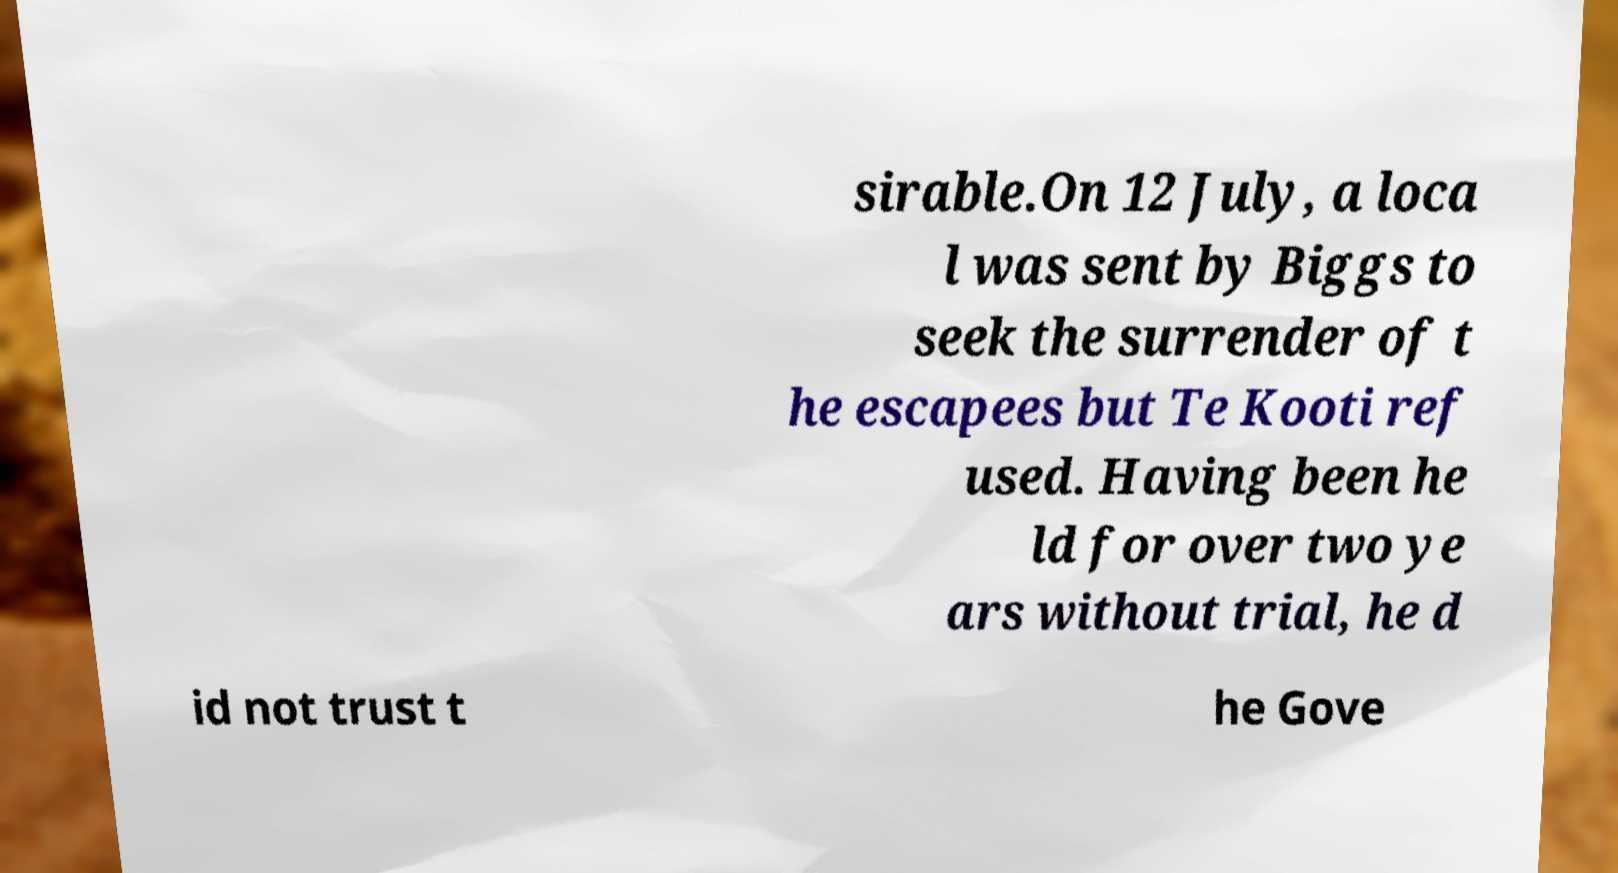For documentation purposes, I need the text within this image transcribed. Could you provide that? sirable.On 12 July, a loca l was sent by Biggs to seek the surrender of t he escapees but Te Kooti ref used. Having been he ld for over two ye ars without trial, he d id not trust t he Gove 